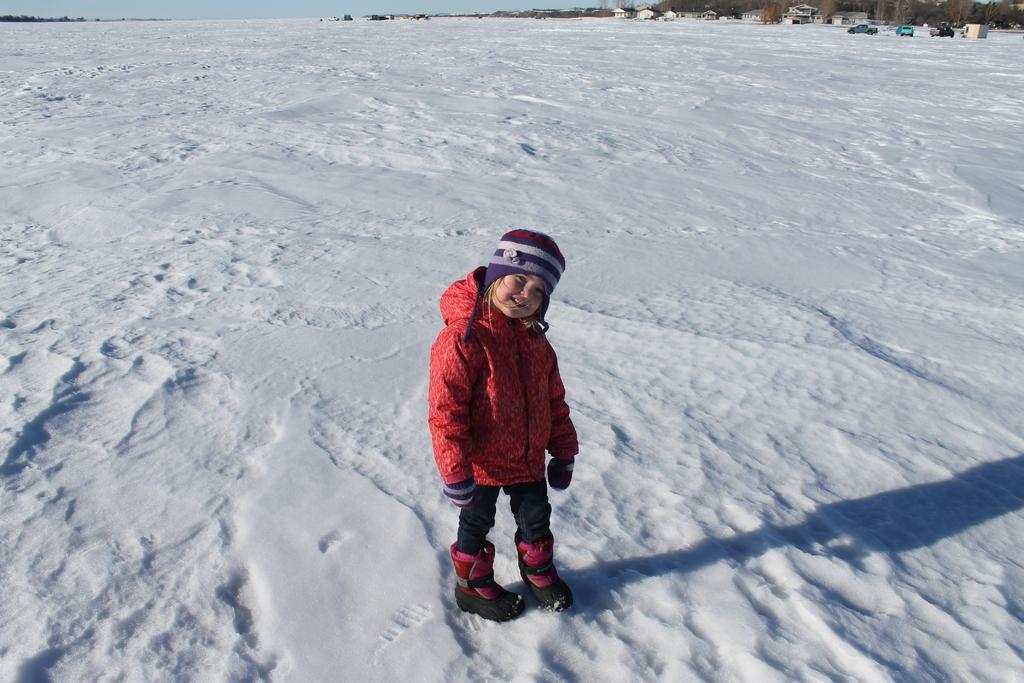What is the main subject of the image? The main subject of the image is a kid. What is the kid doing in the image? The kid is standing on a snow surface and smiling. What can be seen in the background of the image? There are cars, trees, and houses visible in the background of the image. What type of leather is the kid wearing in the image? There is no leather visible in the image; the kid is standing on a snow surface and is not wearing any leather items. 